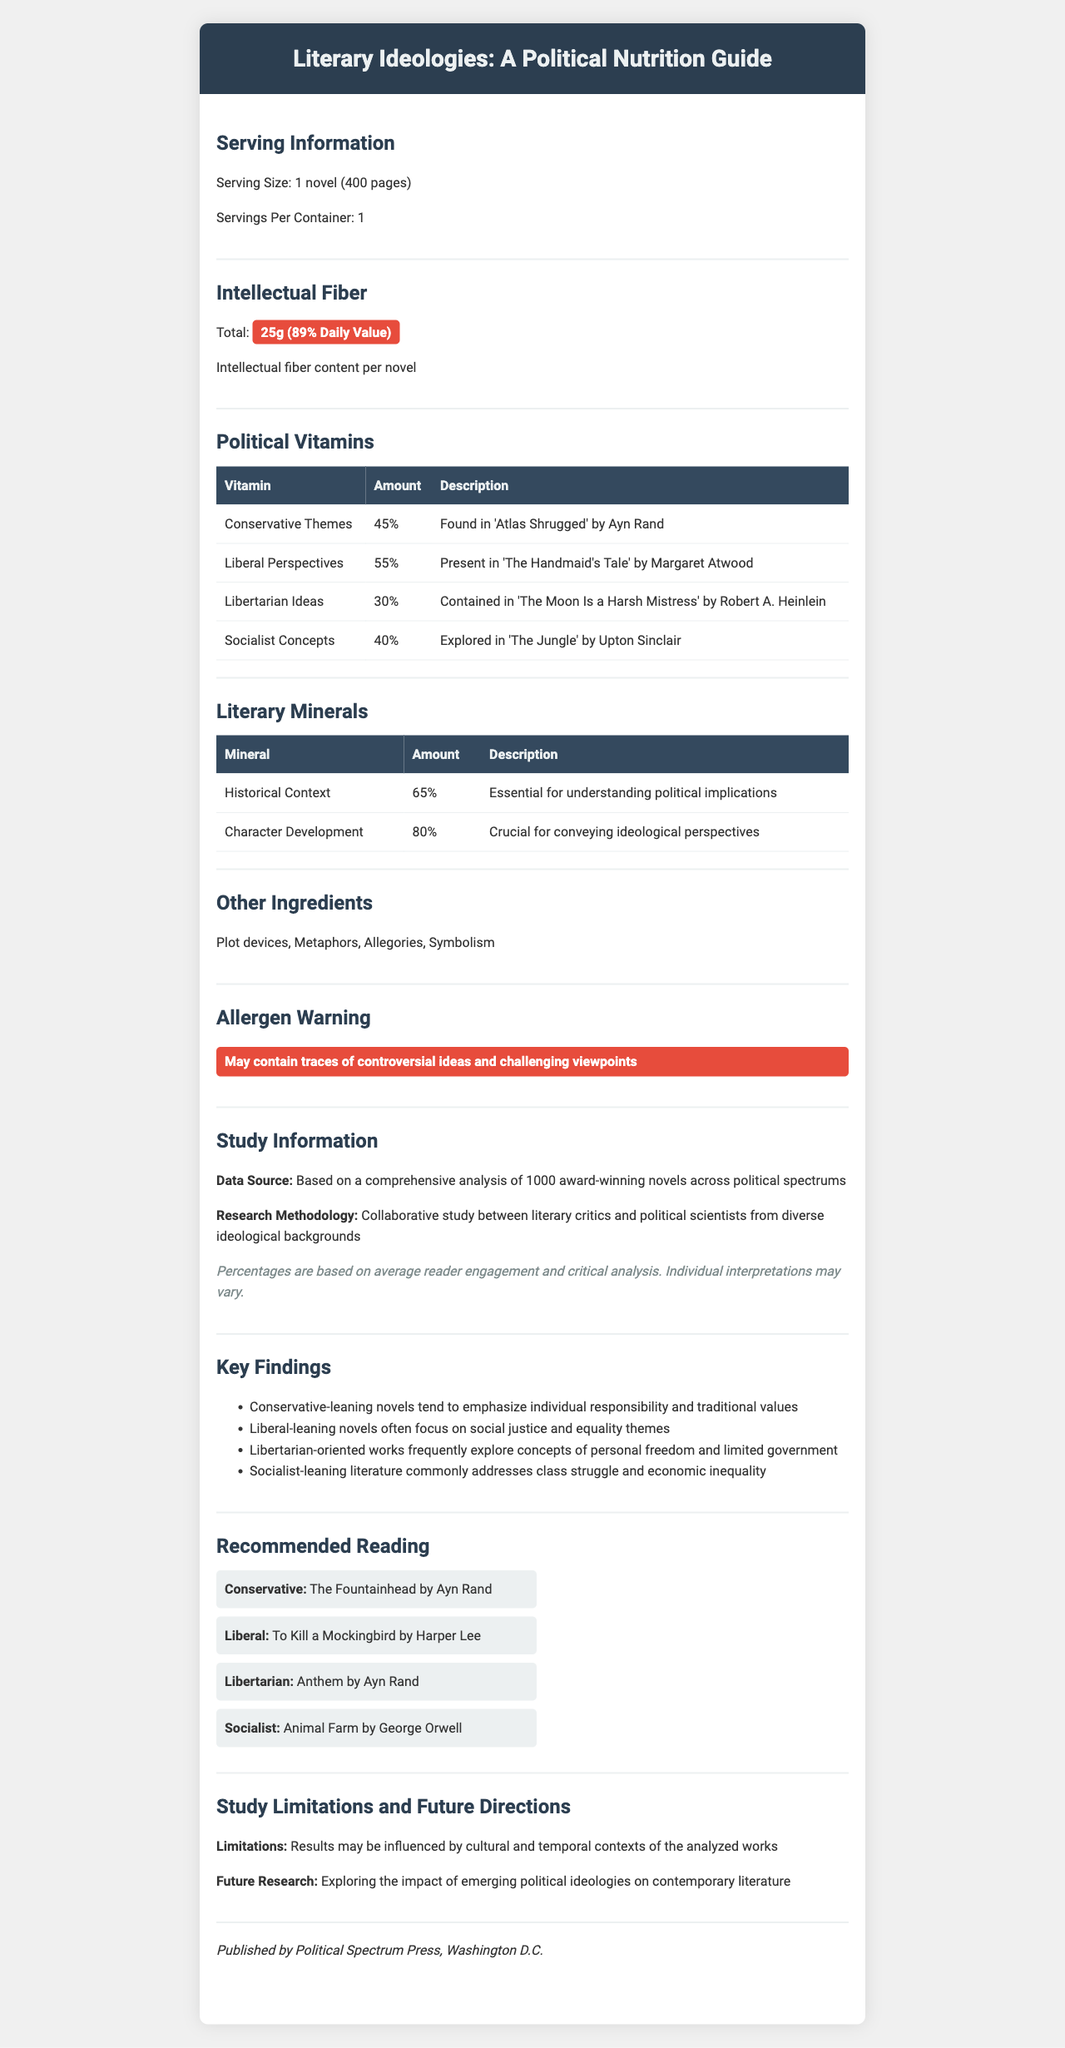what is the serving size for the novels? The document states the serving size is 1 novel (400 pages).
Answer: 1 novel (400 pages) how much intellectual fiber does one novel contain? The document shows that one novel contains 25g of intellectual fiber.
Answer: 25g Which novel is associated with libertarian ideas? The table under "Political Vitamins" lists "The Moon Is a Harsh Mistress" by Robert A. Heinlein as containing 30% libertarian ideas.
Answer: The Moon Is a Harsh Mistress by Robert A. Heinlein what is the allergen warning for these novels? The allergen warning is explicitly mentioned in its own section.
Answer: May contain traces of controversial ideas and challenging viewpoints what percentage of conservative themes is typically found in these novels? The document states that conservative themes amount to 45%, mainly found in "Atlas Shrugged" by Ayn Rand.
Answer: 45% which vitamin has the highest percentage in the novels? A. Conservative Themes B. Liberal Perspectives C. Libertarian Ideas D. Socialist Concepts Liberal Perspectives are listed as 55%, which is the highest among the vitamins.
Answer: B. Liberal Perspectives which mineral is more abundant in the novels? A. Historical Context B. Character Development Character Development is at 80%, which is greater than Historical Context at 65%.
Answer: B. Character Development are cultural and temporal contexts considered in the study results? The study limitations section mentions that results may be influenced by cultural and temporal contexts of the analyzed works.
Answer: Yes summarize the main idea of the document. The document mimics a nutrition facts label, summarizing a literary study that analyzes the ideological content of novels, including their thematic elements and contextual significance.
Answer: The document is a nutrition facts-style guide titled "Literary Ideologies: A Political Nutrition Guide" that provides detailed information about the "intellectual fiber," political "vitamins," and literary "minerals" found in award-winning novels across various political affiliations. It includes serving sizes, key findings from the collaborative study, recommended readings, and mentions of study limitations and future research directions. what is the methodology of the study? The research methodology section states this explicitly.
Answer: Collaborative study between literary critics and political scientists from diverse ideological backgrounds which novel is recommended for socialist readers? A. Atlas Shrugged B. The Handmaid's Tale C. Anthem D. Animal Farm "Animal Farm" by George Orwell is recommended for socialist readers, as per the recommended reading section.
Answer: D. Animal Farm how much historical context is considered essential in these novels? The listed percentage for historical context in the document is 65%.
Answer: 65% who published the guide? The manufacturer info section states this.
Answer: Political Spectrum Press, Washington D.C. does this document contain coding details? The document provides nutritional-style information about novels and doesn't cover coding details.
Answer: Not enough information does the daily value percentage for intellectual fiber imply an actual nutritional daily value? The daily value percentage is metaphorical, referring to "intellectual fiber content per novel," not physical nutrition.
Answer: No 